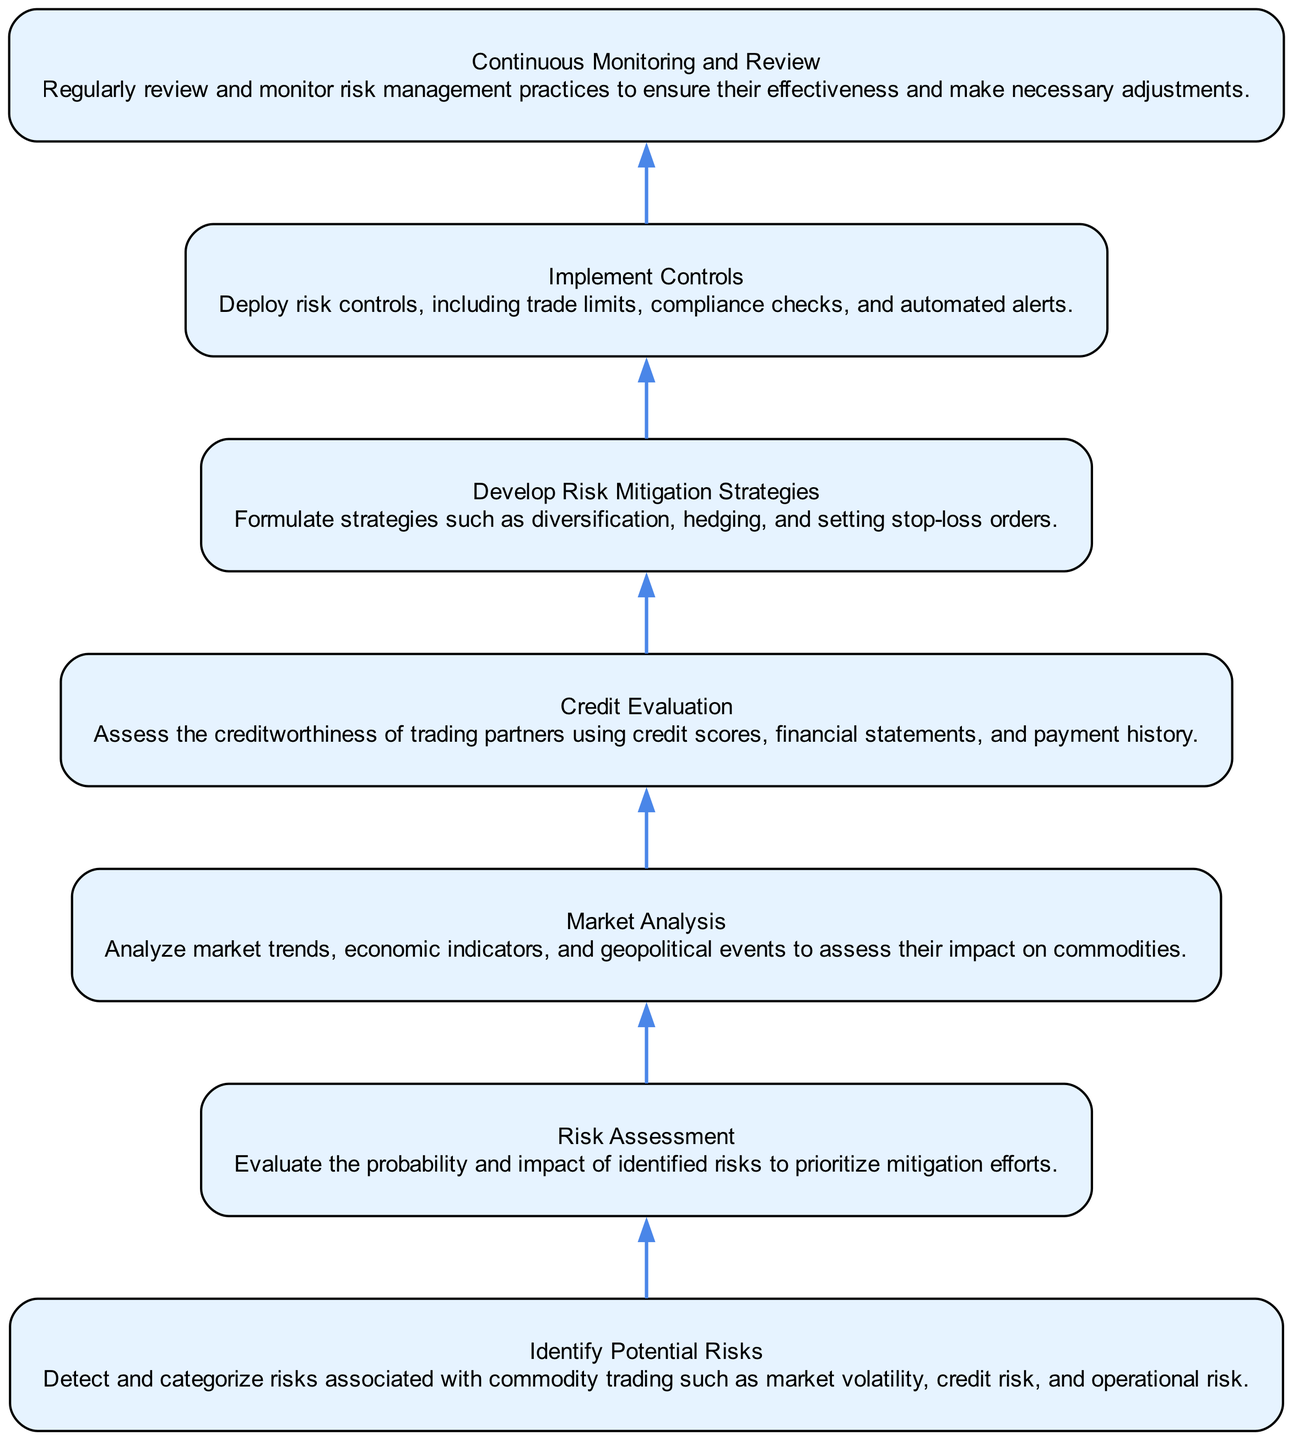what is the first step in the risk management procedure? The first step, as depicted in the diagram, is "Identify Potential Risks," which is located at the bottom of the flow chart.
Answer: Identify Potential Risks how many nodes are in the diagram? By counting the number of distinct boxed elements in the diagram, we find there are seven nodes in total.
Answer: 7 what is the last step of the procedure? The last step is "Continuous Monitoring and Review," situated at the top of the flow chart, indicating it is the final action in the risk management procedure.
Answer: Continuous Monitoring and Review which steps follow the "Risk Assessment" step? The step that follows "Risk Assessment" in the upward flow of the diagram is "Develop Risk Mitigation Strategies."
Answer: Develop Risk Mitigation Strategies what is the relationship between "Market Analysis" and "Risk Assessment"? "Market Analysis" is a precursor to the "Risk Assessment" step, indicating that insights from market analysis feed into how risks are assessed thereafter.
Answer: Market Analysis feeds into Risk Assessment what are two strategies mentioned under "Develop Risk Mitigation Strategies"? Two strategies listed in this step are "diversification" and "hedging," both of which are common risk mitigation approaches in trading.
Answer: diversification, hedging what is the purpose of the "Implement Controls" step in the diagram? The "Implement Controls" step serves to apply specific risk control measures, such as trade limits and compliance checks, to reduce identified risks.
Answer: apply risk control measures how does "Continuous Monitoring and Review" relate to "Implement Controls"? "Continuous Monitoring and Review" occurs after "Implement Controls," allowing for the evaluation and potential adjustment of the controls that were put in place.
Answer: evaluates and adjusts controls 